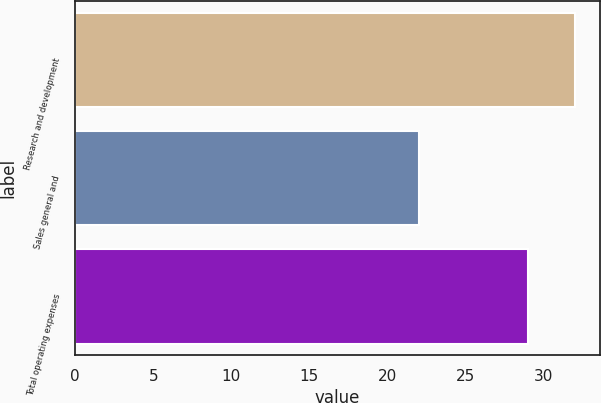Convert chart. <chart><loc_0><loc_0><loc_500><loc_500><bar_chart><fcel>Research and development<fcel>Sales general and<fcel>Total operating expenses<nl><fcel>32<fcel>22<fcel>29<nl></chart> 